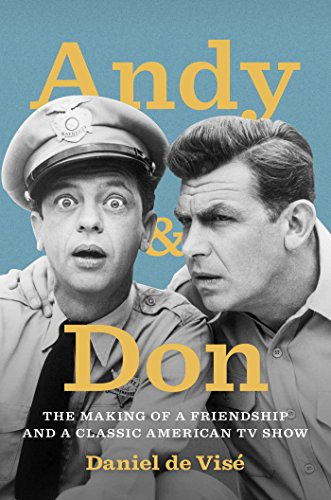What is the genre of this book? This book belongs to the genre of 'Humor & Entertainment', a fitting category for a work that examines the behind-the-scenes elements of a famous comedy show. 